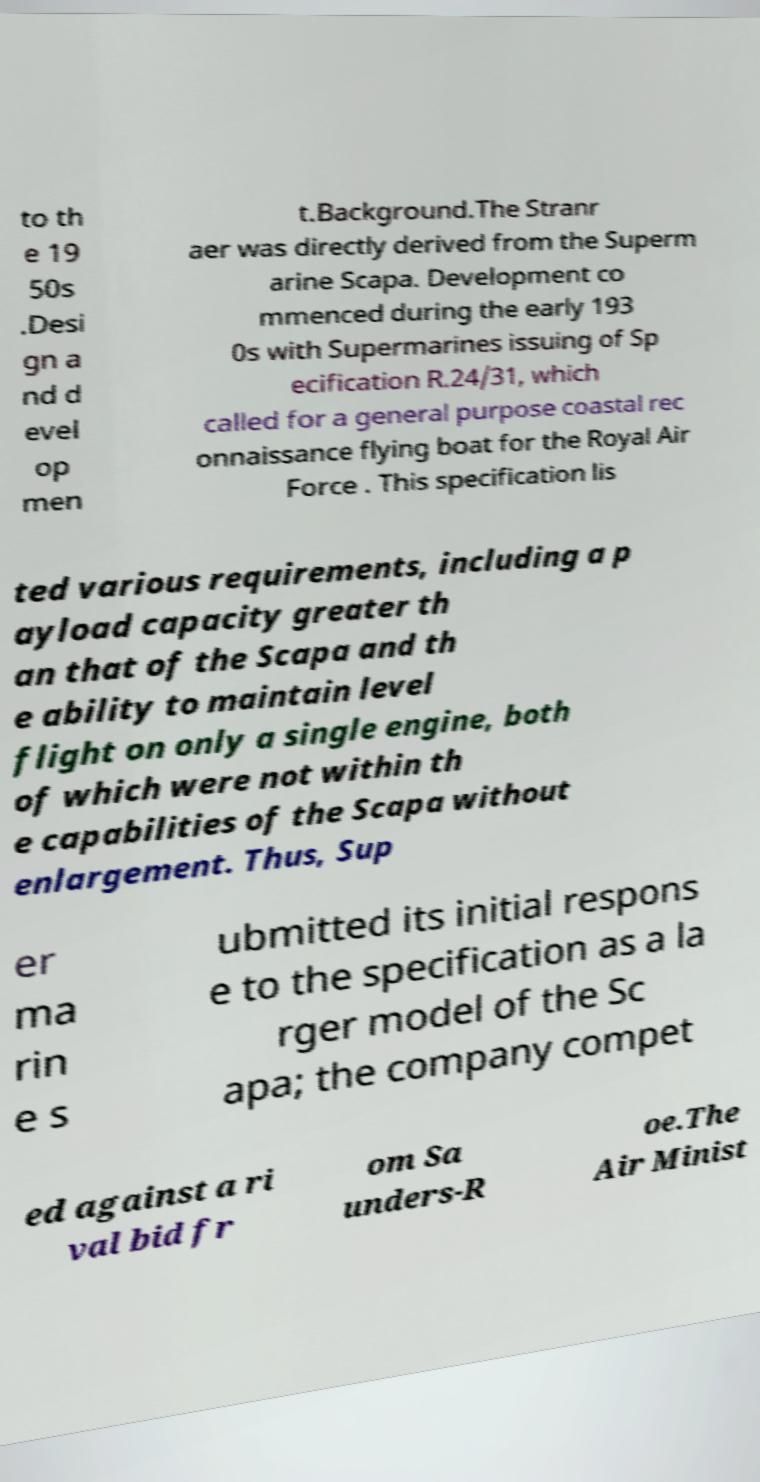Can you accurately transcribe the text from the provided image for me? to th e 19 50s .Desi gn a nd d evel op men t.Background.The Stranr aer was directly derived from the Superm arine Scapa. Development co mmenced during the early 193 0s with Supermarines issuing of Sp ecification R.24/31, which called for a general purpose coastal rec onnaissance flying boat for the Royal Air Force . This specification lis ted various requirements, including a p ayload capacity greater th an that of the Scapa and th e ability to maintain level flight on only a single engine, both of which were not within th e capabilities of the Scapa without enlargement. Thus, Sup er ma rin e s ubmitted its initial respons e to the specification as a la rger model of the Sc apa; the company compet ed against a ri val bid fr om Sa unders-R oe.The Air Minist 